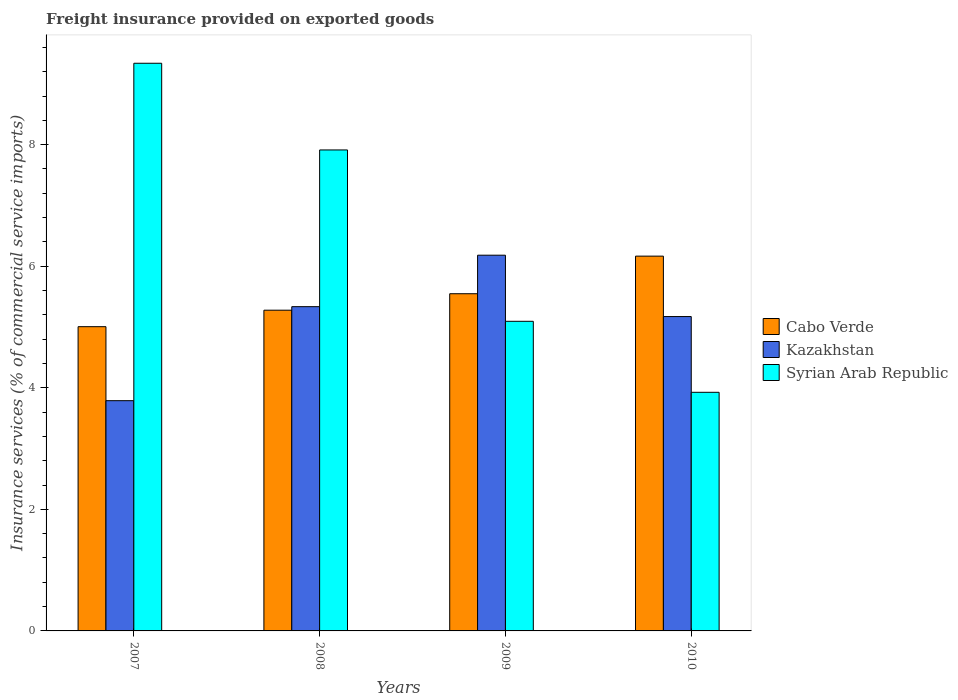How many different coloured bars are there?
Offer a terse response. 3. How many groups of bars are there?
Your answer should be compact. 4. How many bars are there on the 2nd tick from the left?
Your response must be concise. 3. What is the label of the 2nd group of bars from the left?
Keep it short and to the point. 2008. In how many cases, is the number of bars for a given year not equal to the number of legend labels?
Your response must be concise. 0. What is the freight insurance provided on exported goods in Cabo Verde in 2010?
Your answer should be very brief. 6.17. Across all years, what is the maximum freight insurance provided on exported goods in Kazakhstan?
Your answer should be very brief. 6.18. Across all years, what is the minimum freight insurance provided on exported goods in Kazakhstan?
Offer a very short reply. 3.79. In which year was the freight insurance provided on exported goods in Syrian Arab Republic maximum?
Give a very brief answer. 2007. What is the total freight insurance provided on exported goods in Syrian Arab Republic in the graph?
Your response must be concise. 26.27. What is the difference between the freight insurance provided on exported goods in Syrian Arab Republic in 2007 and that in 2008?
Your answer should be compact. 1.43. What is the difference between the freight insurance provided on exported goods in Kazakhstan in 2010 and the freight insurance provided on exported goods in Cabo Verde in 2009?
Your answer should be compact. -0.38. What is the average freight insurance provided on exported goods in Cabo Verde per year?
Provide a short and direct response. 5.5. In the year 2008, what is the difference between the freight insurance provided on exported goods in Cabo Verde and freight insurance provided on exported goods in Syrian Arab Republic?
Keep it short and to the point. -2.64. In how many years, is the freight insurance provided on exported goods in Kazakhstan greater than 8 %?
Ensure brevity in your answer.  0. What is the ratio of the freight insurance provided on exported goods in Kazakhstan in 2008 to that in 2009?
Provide a succinct answer. 0.86. Is the freight insurance provided on exported goods in Kazakhstan in 2008 less than that in 2010?
Make the answer very short. No. What is the difference between the highest and the second highest freight insurance provided on exported goods in Cabo Verde?
Provide a succinct answer. 0.62. What is the difference between the highest and the lowest freight insurance provided on exported goods in Syrian Arab Republic?
Provide a short and direct response. 5.41. Is the sum of the freight insurance provided on exported goods in Cabo Verde in 2008 and 2010 greater than the maximum freight insurance provided on exported goods in Kazakhstan across all years?
Your answer should be compact. Yes. What does the 1st bar from the left in 2007 represents?
Provide a short and direct response. Cabo Verde. What does the 2nd bar from the right in 2010 represents?
Keep it short and to the point. Kazakhstan. Is it the case that in every year, the sum of the freight insurance provided on exported goods in Kazakhstan and freight insurance provided on exported goods in Syrian Arab Republic is greater than the freight insurance provided on exported goods in Cabo Verde?
Offer a very short reply. Yes. How many bars are there?
Make the answer very short. 12. What is the difference between two consecutive major ticks on the Y-axis?
Keep it short and to the point. 2. Where does the legend appear in the graph?
Make the answer very short. Center right. How many legend labels are there?
Make the answer very short. 3. What is the title of the graph?
Your answer should be very brief. Freight insurance provided on exported goods. What is the label or title of the Y-axis?
Make the answer very short. Insurance services (% of commercial service imports). What is the Insurance services (% of commercial service imports) in Cabo Verde in 2007?
Make the answer very short. 5.01. What is the Insurance services (% of commercial service imports) in Kazakhstan in 2007?
Ensure brevity in your answer.  3.79. What is the Insurance services (% of commercial service imports) of Syrian Arab Republic in 2007?
Make the answer very short. 9.34. What is the Insurance services (% of commercial service imports) of Cabo Verde in 2008?
Your response must be concise. 5.28. What is the Insurance services (% of commercial service imports) of Kazakhstan in 2008?
Keep it short and to the point. 5.33. What is the Insurance services (% of commercial service imports) in Syrian Arab Republic in 2008?
Make the answer very short. 7.91. What is the Insurance services (% of commercial service imports) in Cabo Verde in 2009?
Provide a succinct answer. 5.55. What is the Insurance services (% of commercial service imports) of Kazakhstan in 2009?
Keep it short and to the point. 6.18. What is the Insurance services (% of commercial service imports) in Syrian Arab Republic in 2009?
Offer a very short reply. 5.09. What is the Insurance services (% of commercial service imports) of Cabo Verde in 2010?
Provide a succinct answer. 6.17. What is the Insurance services (% of commercial service imports) of Kazakhstan in 2010?
Give a very brief answer. 5.17. What is the Insurance services (% of commercial service imports) in Syrian Arab Republic in 2010?
Your answer should be compact. 3.93. Across all years, what is the maximum Insurance services (% of commercial service imports) of Cabo Verde?
Offer a very short reply. 6.17. Across all years, what is the maximum Insurance services (% of commercial service imports) in Kazakhstan?
Make the answer very short. 6.18. Across all years, what is the maximum Insurance services (% of commercial service imports) of Syrian Arab Republic?
Ensure brevity in your answer.  9.34. Across all years, what is the minimum Insurance services (% of commercial service imports) of Cabo Verde?
Make the answer very short. 5.01. Across all years, what is the minimum Insurance services (% of commercial service imports) of Kazakhstan?
Offer a very short reply. 3.79. Across all years, what is the minimum Insurance services (% of commercial service imports) in Syrian Arab Republic?
Your response must be concise. 3.93. What is the total Insurance services (% of commercial service imports) in Cabo Verde in the graph?
Your response must be concise. 22. What is the total Insurance services (% of commercial service imports) in Kazakhstan in the graph?
Your answer should be compact. 20.48. What is the total Insurance services (% of commercial service imports) in Syrian Arab Republic in the graph?
Your response must be concise. 26.27. What is the difference between the Insurance services (% of commercial service imports) of Cabo Verde in 2007 and that in 2008?
Ensure brevity in your answer.  -0.27. What is the difference between the Insurance services (% of commercial service imports) of Kazakhstan in 2007 and that in 2008?
Your response must be concise. -1.55. What is the difference between the Insurance services (% of commercial service imports) of Syrian Arab Republic in 2007 and that in 2008?
Make the answer very short. 1.43. What is the difference between the Insurance services (% of commercial service imports) of Cabo Verde in 2007 and that in 2009?
Offer a terse response. -0.54. What is the difference between the Insurance services (% of commercial service imports) of Kazakhstan in 2007 and that in 2009?
Your answer should be very brief. -2.39. What is the difference between the Insurance services (% of commercial service imports) of Syrian Arab Republic in 2007 and that in 2009?
Provide a short and direct response. 4.25. What is the difference between the Insurance services (% of commercial service imports) of Cabo Verde in 2007 and that in 2010?
Provide a short and direct response. -1.16. What is the difference between the Insurance services (% of commercial service imports) of Kazakhstan in 2007 and that in 2010?
Your answer should be very brief. -1.38. What is the difference between the Insurance services (% of commercial service imports) in Syrian Arab Republic in 2007 and that in 2010?
Make the answer very short. 5.41. What is the difference between the Insurance services (% of commercial service imports) of Cabo Verde in 2008 and that in 2009?
Provide a succinct answer. -0.27. What is the difference between the Insurance services (% of commercial service imports) of Kazakhstan in 2008 and that in 2009?
Give a very brief answer. -0.85. What is the difference between the Insurance services (% of commercial service imports) of Syrian Arab Republic in 2008 and that in 2009?
Make the answer very short. 2.82. What is the difference between the Insurance services (% of commercial service imports) in Cabo Verde in 2008 and that in 2010?
Make the answer very short. -0.89. What is the difference between the Insurance services (% of commercial service imports) of Kazakhstan in 2008 and that in 2010?
Provide a succinct answer. 0.16. What is the difference between the Insurance services (% of commercial service imports) in Syrian Arab Republic in 2008 and that in 2010?
Your answer should be compact. 3.99. What is the difference between the Insurance services (% of commercial service imports) of Cabo Verde in 2009 and that in 2010?
Give a very brief answer. -0.62. What is the difference between the Insurance services (% of commercial service imports) of Kazakhstan in 2009 and that in 2010?
Offer a terse response. 1.01. What is the difference between the Insurance services (% of commercial service imports) in Syrian Arab Republic in 2009 and that in 2010?
Provide a succinct answer. 1.17. What is the difference between the Insurance services (% of commercial service imports) in Cabo Verde in 2007 and the Insurance services (% of commercial service imports) in Kazakhstan in 2008?
Give a very brief answer. -0.33. What is the difference between the Insurance services (% of commercial service imports) of Cabo Verde in 2007 and the Insurance services (% of commercial service imports) of Syrian Arab Republic in 2008?
Your response must be concise. -2.91. What is the difference between the Insurance services (% of commercial service imports) in Kazakhstan in 2007 and the Insurance services (% of commercial service imports) in Syrian Arab Republic in 2008?
Provide a succinct answer. -4.13. What is the difference between the Insurance services (% of commercial service imports) of Cabo Verde in 2007 and the Insurance services (% of commercial service imports) of Kazakhstan in 2009?
Your answer should be compact. -1.18. What is the difference between the Insurance services (% of commercial service imports) in Cabo Verde in 2007 and the Insurance services (% of commercial service imports) in Syrian Arab Republic in 2009?
Your answer should be compact. -0.09. What is the difference between the Insurance services (% of commercial service imports) of Kazakhstan in 2007 and the Insurance services (% of commercial service imports) of Syrian Arab Republic in 2009?
Offer a very short reply. -1.31. What is the difference between the Insurance services (% of commercial service imports) in Cabo Verde in 2007 and the Insurance services (% of commercial service imports) in Kazakhstan in 2010?
Your answer should be compact. -0.17. What is the difference between the Insurance services (% of commercial service imports) in Cabo Verde in 2007 and the Insurance services (% of commercial service imports) in Syrian Arab Republic in 2010?
Provide a short and direct response. 1.08. What is the difference between the Insurance services (% of commercial service imports) in Kazakhstan in 2007 and the Insurance services (% of commercial service imports) in Syrian Arab Republic in 2010?
Ensure brevity in your answer.  -0.14. What is the difference between the Insurance services (% of commercial service imports) of Cabo Verde in 2008 and the Insurance services (% of commercial service imports) of Kazakhstan in 2009?
Provide a short and direct response. -0.91. What is the difference between the Insurance services (% of commercial service imports) in Cabo Verde in 2008 and the Insurance services (% of commercial service imports) in Syrian Arab Republic in 2009?
Provide a short and direct response. 0.18. What is the difference between the Insurance services (% of commercial service imports) of Kazakhstan in 2008 and the Insurance services (% of commercial service imports) of Syrian Arab Republic in 2009?
Offer a very short reply. 0.24. What is the difference between the Insurance services (% of commercial service imports) in Cabo Verde in 2008 and the Insurance services (% of commercial service imports) in Kazakhstan in 2010?
Provide a short and direct response. 0.1. What is the difference between the Insurance services (% of commercial service imports) of Cabo Verde in 2008 and the Insurance services (% of commercial service imports) of Syrian Arab Republic in 2010?
Provide a short and direct response. 1.35. What is the difference between the Insurance services (% of commercial service imports) in Kazakhstan in 2008 and the Insurance services (% of commercial service imports) in Syrian Arab Republic in 2010?
Provide a succinct answer. 1.41. What is the difference between the Insurance services (% of commercial service imports) in Cabo Verde in 2009 and the Insurance services (% of commercial service imports) in Kazakhstan in 2010?
Your response must be concise. 0.38. What is the difference between the Insurance services (% of commercial service imports) in Cabo Verde in 2009 and the Insurance services (% of commercial service imports) in Syrian Arab Republic in 2010?
Provide a short and direct response. 1.62. What is the difference between the Insurance services (% of commercial service imports) in Kazakhstan in 2009 and the Insurance services (% of commercial service imports) in Syrian Arab Republic in 2010?
Your answer should be compact. 2.26. What is the average Insurance services (% of commercial service imports) of Cabo Verde per year?
Your answer should be very brief. 5.5. What is the average Insurance services (% of commercial service imports) of Kazakhstan per year?
Offer a terse response. 5.12. What is the average Insurance services (% of commercial service imports) in Syrian Arab Republic per year?
Make the answer very short. 6.57. In the year 2007, what is the difference between the Insurance services (% of commercial service imports) in Cabo Verde and Insurance services (% of commercial service imports) in Kazakhstan?
Ensure brevity in your answer.  1.22. In the year 2007, what is the difference between the Insurance services (% of commercial service imports) of Cabo Verde and Insurance services (% of commercial service imports) of Syrian Arab Republic?
Make the answer very short. -4.33. In the year 2007, what is the difference between the Insurance services (% of commercial service imports) of Kazakhstan and Insurance services (% of commercial service imports) of Syrian Arab Republic?
Ensure brevity in your answer.  -5.55. In the year 2008, what is the difference between the Insurance services (% of commercial service imports) of Cabo Verde and Insurance services (% of commercial service imports) of Kazakhstan?
Your response must be concise. -0.06. In the year 2008, what is the difference between the Insurance services (% of commercial service imports) in Cabo Verde and Insurance services (% of commercial service imports) in Syrian Arab Republic?
Ensure brevity in your answer.  -2.64. In the year 2008, what is the difference between the Insurance services (% of commercial service imports) of Kazakhstan and Insurance services (% of commercial service imports) of Syrian Arab Republic?
Keep it short and to the point. -2.58. In the year 2009, what is the difference between the Insurance services (% of commercial service imports) in Cabo Verde and Insurance services (% of commercial service imports) in Kazakhstan?
Your response must be concise. -0.63. In the year 2009, what is the difference between the Insurance services (% of commercial service imports) of Cabo Verde and Insurance services (% of commercial service imports) of Syrian Arab Republic?
Ensure brevity in your answer.  0.45. In the year 2009, what is the difference between the Insurance services (% of commercial service imports) in Kazakhstan and Insurance services (% of commercial service imports) in Syrian Arab Republic?
Keep it short and to the point. 1.09. In the year 2010, what is the difference between the Insurance services (% of commercial service imports) in Cabo Verde and Insurance services (% of commercial service imports) in Kazakhstan?
Your answer should be very brief. 0.99. In the year 2010, what is the difference between the Insurance services (% of commercial service imports) of Cabo Verde and Insurance services (% of commercial service imports) of Syrian Arab Republic?
Ensure brevity in your answer.  2.24. In the year 2010, what is the difference between the Insurance services (% of commercial service imports) of Kazakhstan and Insurance services (% of commercial service imports) of Syrian Arab Republic?
Offer a very short reply. 1.25. What is the ratio of the Insurance services (% of commercial service imports) of Cabo Verde in 2007 to that in 2008?
Give a very brief answer. 0.95. What is the ratio of the Insurance services (% of commercial service imports) in Kazakhstan in 2007 to that in 2008?
Ensure brevity in your answer.  0.71. What is the ratio of the Insurance services (% of commercial service imports) in Syrian Arab Republic in 2007 to that in 2008?
Your answer should be very brief. 1.18. What is the ratio of the Insurance services (% of commercial service imports) of Cabo Verde in 2007 to that in 2009?
Provide a succinct answer. 0.9. What is the ratio of the Insurance services (% of commercial service imports) in Kazakhstan in 2007 to that in 2009?
Offer a very short reply. 0.61. What is the ratio of the Insurance services (% of commercial service imports) in Syrian Arab Republic in 2007 to that in 2009?
Provide a succinct answer. 1.83. What is the ratio of the Insurance services (% of commercial service imports) of Cabo Verde in 2007 to that in 2010?
Provide a short and direct response. 0.81. What is the ratio of the Insurance services (% of commercial service imports) of Kazakhstan in 2007 to that in 2010?
Provide a succinct answer. 0.73. What is the ratio of the Insurance services (% of commercial service imports) in Syrian Arab Republic in 2007 to that in 2010?
Give a very brief answer. 2.38. What is the ratio of the Insurance services (% of commercial service imports) of Cabo Verde in 2008 to that in 2009?
Give a very brief answer. 0.95. What is the ratio of the Insurance services (% of commercial service imports) in Kazakhstan in 2008 to that in 2009?
Provide a short and direct response. 0.86. What is the ratio of the Insurance services (% of commercial service imports) of Syrian Arab Republic in 2008 to that in 2009?
Your answer should be compact. 1.55. What is the ratio of the Insurance services (% of commercial service imports) in Cabo Verde in 2008 to that in 2010?
Your response must be concise. 0.86. What is the ratio of the Insurance services (% of commercial service imports) in Kazakhstan in 2008 to that in 2010?
Ensure brevity in your answer.  1.03. What is the ratio of the Insurance services (% of commercial service imports) in Syrian Arab Republic in 2008 to that in 2010?
Your answer should be very brief. 2.02. What is the ratio of the Insurance services (% of commercial service imports) of Cabo Verde in 2009 to that in 2010?
Offer a very short reply. 0.9. What is the ratio of the Insurance services (% of commercial service imports) of Kazakhstan in 2009 to that in 2010?
Your response must be concise. 1.2. What is the ratio of the Insurance services (% of commercial service imports) in Syrian Arab Republic in 2009 to that in 2010?
Your response must be concise. 1.3. What is the difference between the highest and the second highest Insurance services (% of commercial service imports) in Cabo Verde?
Your answer should be very brief. 0.62. What is the difference between the highest and the second highest Insurance services (% of commercial service imports) in Kazakhstan?
Your response must be concise. 0.85. What is the difference between the highest and the second highest Insurance services (% of commercial service imports) of Syrian Arab Republic?
Your response must be concise. 1.43. What is the difference between the highest and the lowest Insurance services (% of commercial service imports) of Cabo Verde?
Keep it short and to the point. 1.16. What is the difference between the highest and the lowest Insurance services (% of commercial service imports) of Kazakhstan?
Provide a short and direct response. 2.39. What is the difference between the highest and the lowest Insurance services (% of commercial service imports) in Syrian Arab Republic?
Provide a short and direct response. 5.41. 